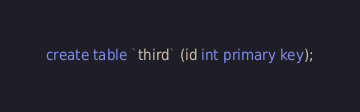Convert code to text. <code><loc_0><loc_0><loc_500><loc_500><_SQL_>create table `third` (id int primary key);
</code> 